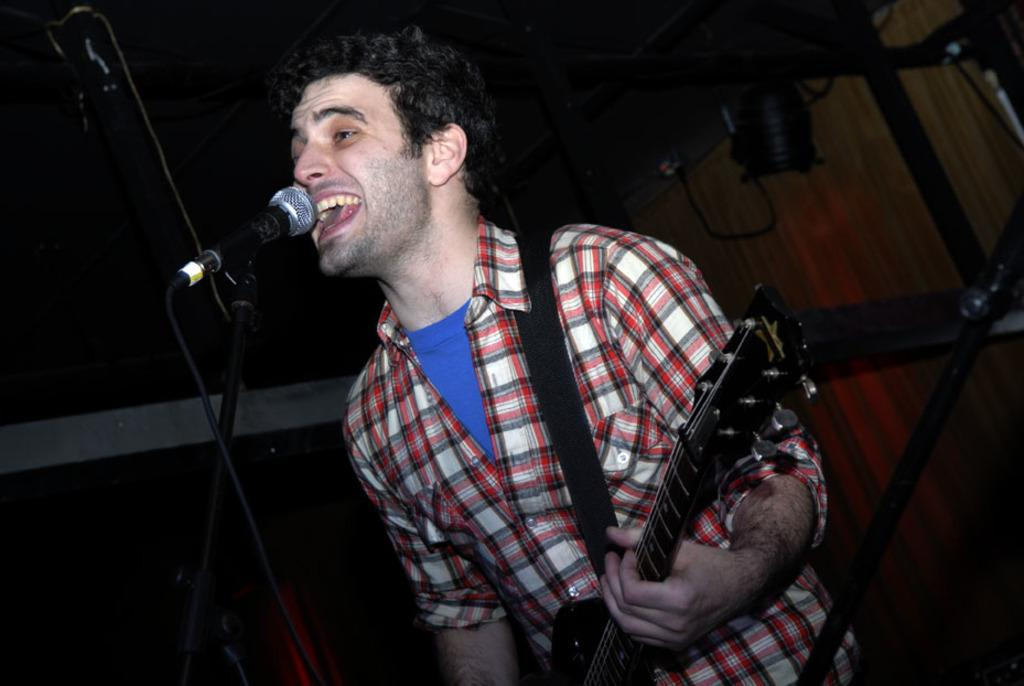What is the man in the image doing? The man is singing on a microphone. What instrument is the man holding in the image? The man is holding a guitar. Can you describe the man's activity in the image? The man is singing and playing the guitar. What type of apparel is the turkey wearing in the image? There is no turkey present in the image, so it is not possible to determine what type of apparel it might be wearing. 